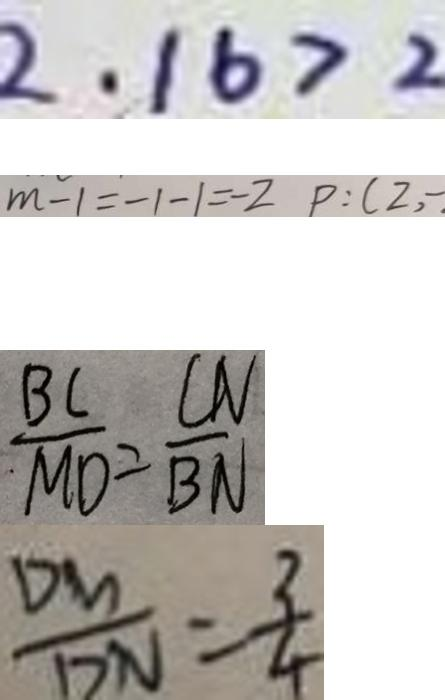Convert formula to latex. <formula><loc_0><loc_0><loc_500><loc_500>2 . 1 6 > 2 
 m - 1 = - 1 - 1 = - 2 P : ( 2 , - 
 \frac { B C } { M D } = \frac { C M } { B N } 
 \frac { D M } { D N } = \frac { 3 } { 4 }</formula> 